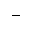<formula> <loc_0><loc_0><loc_500><loc_500>-</formula> 